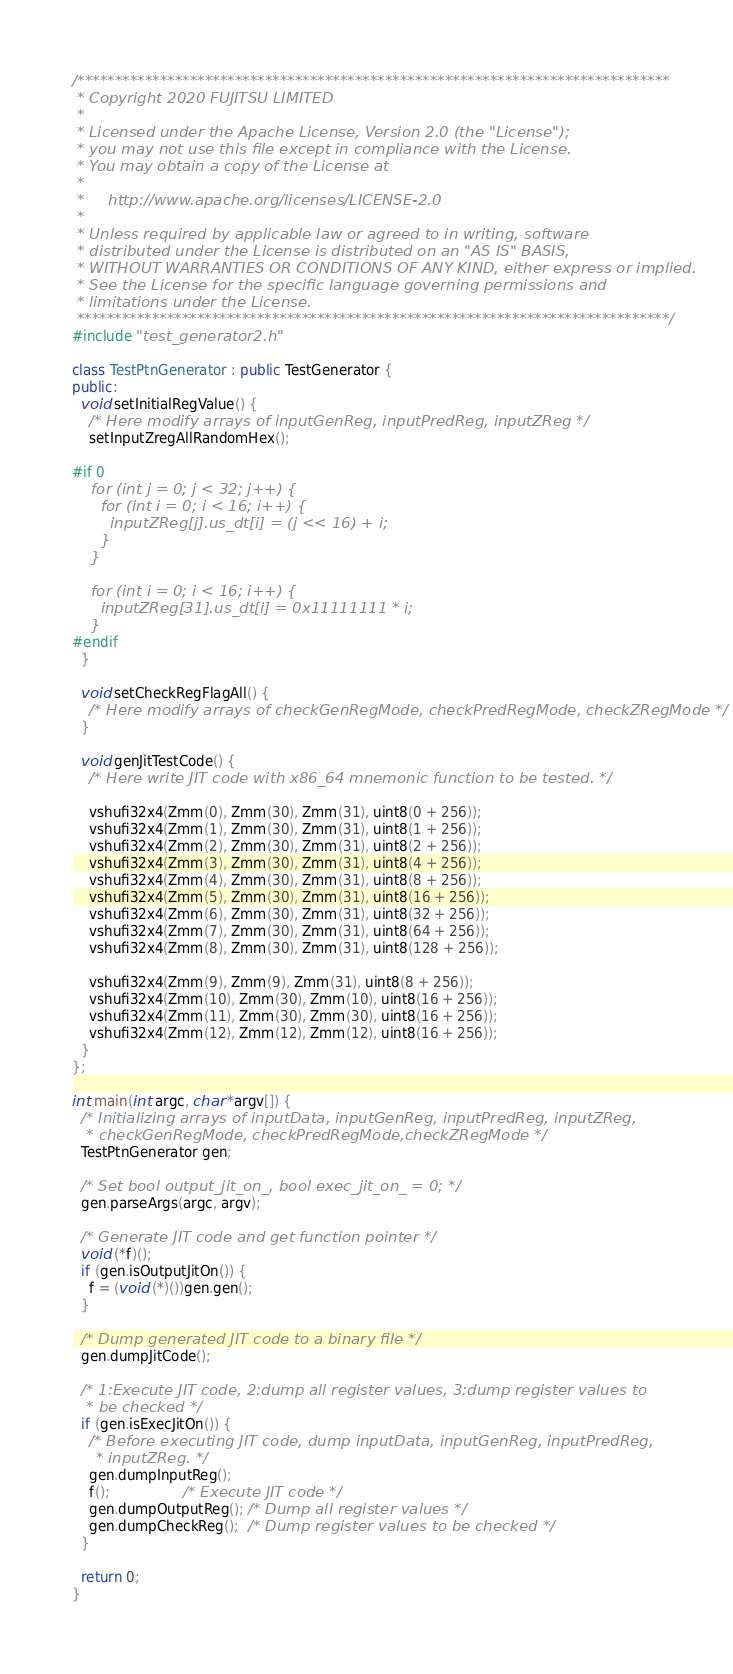<code> <loc_0><loc_0><loc_500><loc_500><_C++_>/*******************************************************************************
 * Copyright 2020 FUJITSU LIMITED
 *
 * Licensed under the Apache License, Version 2.0 (the "License");
 * you may not use this file except in compliance with the License.
 * You may obtain a copy of the License at
 *
 *     http://www.apache.org/licenses/LICENSE-2.0
 *
 * Unless required by applicable law or agreed to in writing, software
 * distributed under the License is distributed on an "AS IS" BASIS,
 * WITHOUT WARRANTIES OR CONDITIONS OF ANY KIND, either express or implied.
 * See the License for the specific language governing permissions and
 * limitations under the License.
 *******************************************************************************/
#include "test_generator2.h"

class TestPtnGenerator : public TestGenerator {
public:
  void setInitialRegValue() {
    /* Here modify arrays of inputGenReg, inputPredReg, inputZReg */
    setInputZregAllRandomHex();

#if 0    
    for (int j = 0; j < 32; j++) {
      for (int i = 0; i < 16; i++) {
        inputZReg[j].us_dt[i] = (j << 16) + i;
      }
    }

    for (int i = 0; i < 16; i++) {
      inputZReg[31].us_dt[i] = 0x11111111 * i;
    }
#endif
  }

  void setCheckRegFlagAll() {
    /* Here modify arrays of checkGenRegMode, checkPredRegMode, checkZRegMode */
  }

  void genJitTestCode() {
    /* Here write JIT code with x86_64 mnemonic function to be tested. */

    vshufi32x4(Zmm(0), Zmm(30), Zmm(31), uint8(0 + 256));
    vshufi32x4(Zmm(1), Zmm(30), Zmm(31), uint8(1 + 256));
    vshufi32x4(Zmm(2), Zmm(30), Zmm(31), uint8(2 + 256));
    vshufi32x4(Zmm(3), Zmm(30), Zmm(31), uint8(4 + 256));
    vshufi32x4(Zmm(4), Zmm(30), Zmm(31), uint8(8 + 256));
    vshufi32x4(Zmm(5), Zmm(30), Zmm(31), uint8(16 + 256));
    vshufi32x4(Zmm(6), Zmm(30), Zmm(31), uint8(32 + 256));
    vshufi32x4(Zmm(7), Zmm(30), Zmm(31), uint8(64 + 256));
    vshufi32x4(Zmm(8), Zmm(30), Zmm(31), uint8(128 + 256));

    vshufi32x4(Zmm(9), Zmm(9), Zmm(31), uint8(8 + 256));
    vshufi32x4(Zmm(10), Zmm(30), Zmm(10), uint8(16 + 256));
    vshufi32x4(Zmm(11), Zmm(30), Zmm(30), uint8(16 + 256));
    vshufi32x4(Zmm(12), Zmm(12), Zmm(12), uint8(16 + 256));
  }
};

int main(int argc, char *argv[]) {
  /* Initializing arrays of inputData, inputGenReg, inputPredReg, inputZReg,
   * checkGenRegMode, checkPredRegMode,checkZRegMode */
  TestPtnGenerator gen;

  /* Set bool output_jit_on_, bool exec_jit_on_ = 0; */
  gen.parseArgs(argc, argv);

  /* Generate JIT code and get function pointer */
  void (*f)();
  if (gen.isOutputJitOn()) {
    f = (void (*)())gen.gen();
  }

  /* Dump generated JIT code to a binary file */
  gen.dumpJitCode();

  /* 1:Execute JIT code, 2:dump all register values, 3:dump register values to
   * be checked */
  if (gen.isExecJitOn()) {
    /* Before executing JIT code, dump inputData, inputGenReg, inputPredReg,
     * inputZReg. */
    gen.dumpInputReg();
    f();                 /* Execute JIT code */
    gen.dumpOutputReg(); /* Dump all register values */
    gen.dumpCheckReg();  /* Dump register values to be checked */
  }

  return 0;
}
</code> 